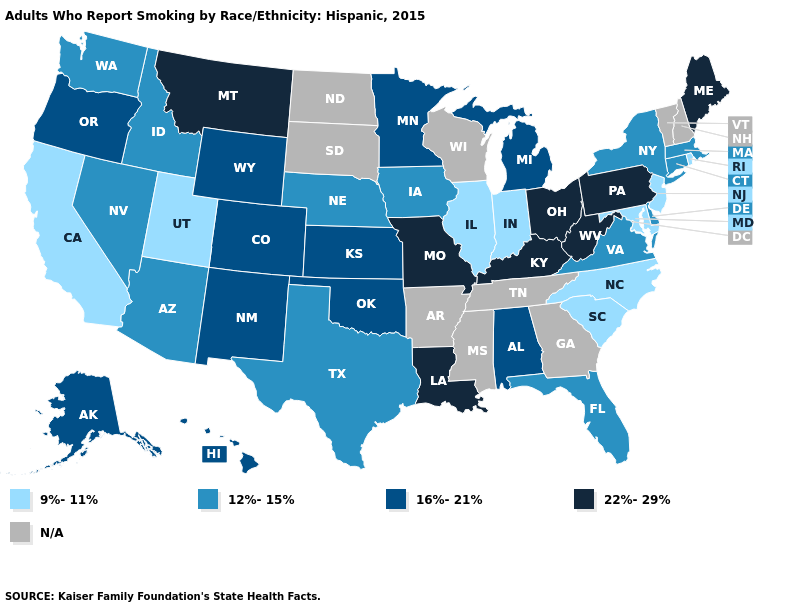Name the states that have a value in the range 22%-29%?
Keep it brief. Kentucky, Louisiana, Maine, Missouri, Montana, Ohio, Pennsylvania, West Virginia. What is the value of Arizona?
Be succinct. 12%-15%. What is the value of Illinois?
Write a very short answer. 9%-11%. Among the states that border Pennsylvania , which have the lowest value?
Quick response, please. Maryland, New Jersey. What is the value of Arizona?
Be succinct. 12%-15%. Which states have the highest value in the USA?
Quick response, please. Kentucky, Louisiana, Maine, Missouri, Montana, Ohio, Pennsylvania, West Virginia. Name the states that have a value in the range 22%-29%?
Write a very short answer. Kentucky, Louisiana, Maine, Missouri, Montana, Ohio, Pennsylvania, West Virginia. Name the states that have a value in the range N/A?
Answer briefly. Arkansas, Georgia, Mississippi, New Hampshire, North Dakota, South Dakota, Tennessee, Vermont, Wisconsin. Which states have the highest value in the USA?
Write a very short answer. Kentucky, Louisiana, Maine, Missouri, Montana, Ohio, Pennsylvania, West Virginia. Name the states that have a value in the range 16%-21%?
Quick response, please. Alabama, Alaska, Colorado, Hawaii, Kansas, Michigan, Minnesota, New Mexico, Oklahoma, Oregon, Wyoming. Among the states that border Minnesota , which have the highest value?
Write a very short answer. Iowa. What is the value of Connecticut?
Short answer required. 12%-15%. Does the first symbol in the legend represent the smallest category?
Write a very short answer. Yes. Is the legend a continuous bar?
Answer briefly. No. 